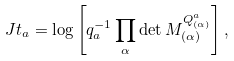<formula> <loc_0><loc_0><loc_500><loc_500>\ J t _ { a } = \log \left [ q _ { a } ^ { - 1 } \prod _ { \alpha } \det M _ { ( \alpha ) } ^ { Q _ { ( \alpha ) } ^ { a } } \right ] ,</formula> 